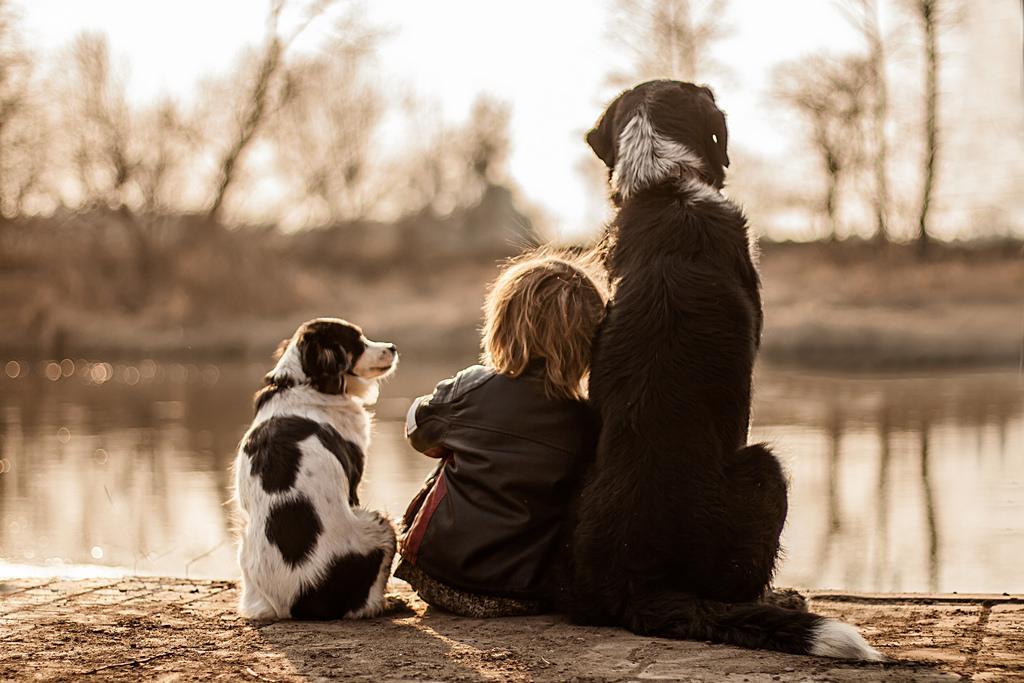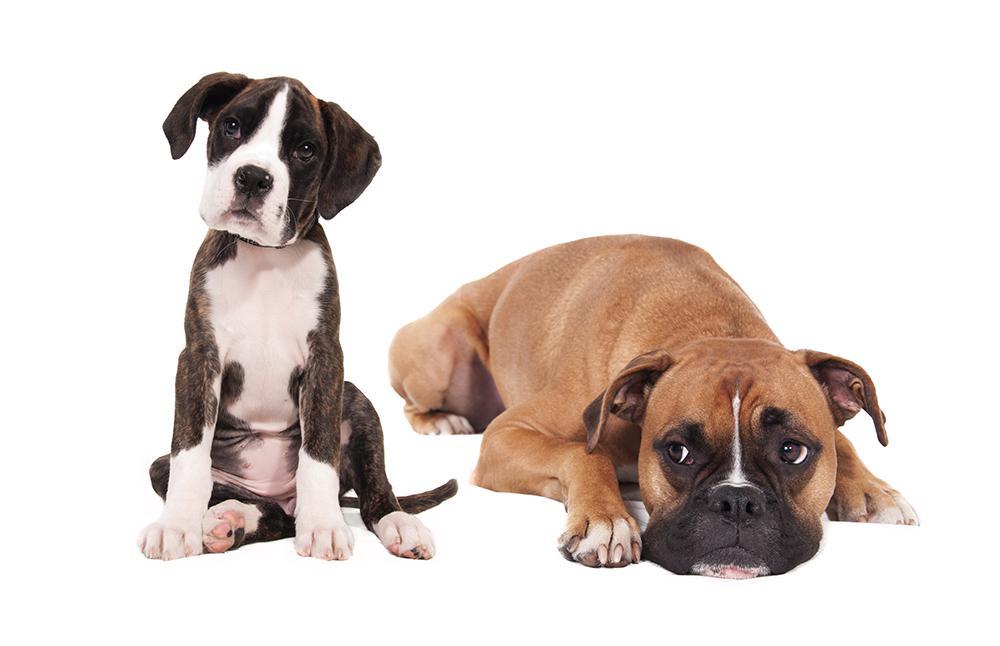The first image is the image on the left, the second image is the image on the right. Examine the images to the left and right. Is the description "The image on the right shows two dogs sitting next to each other outside." accurate? Answer yes or no. No. The first image is the image on the left, the second image is the image on the right. Examine the images to the left and right. Is the description "In at least one of the images, two dog from the same breed are sitting next to each other." accurate? Answer yes or no. No. 